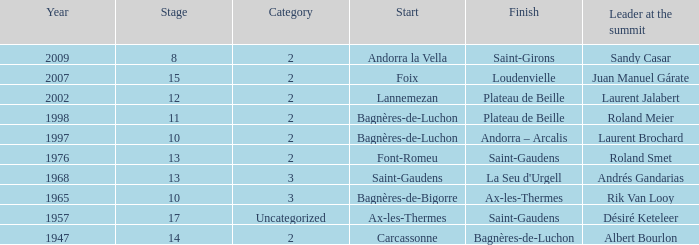Give the Finish for a Stage that is larger than 15 Saint-Gaudens. 